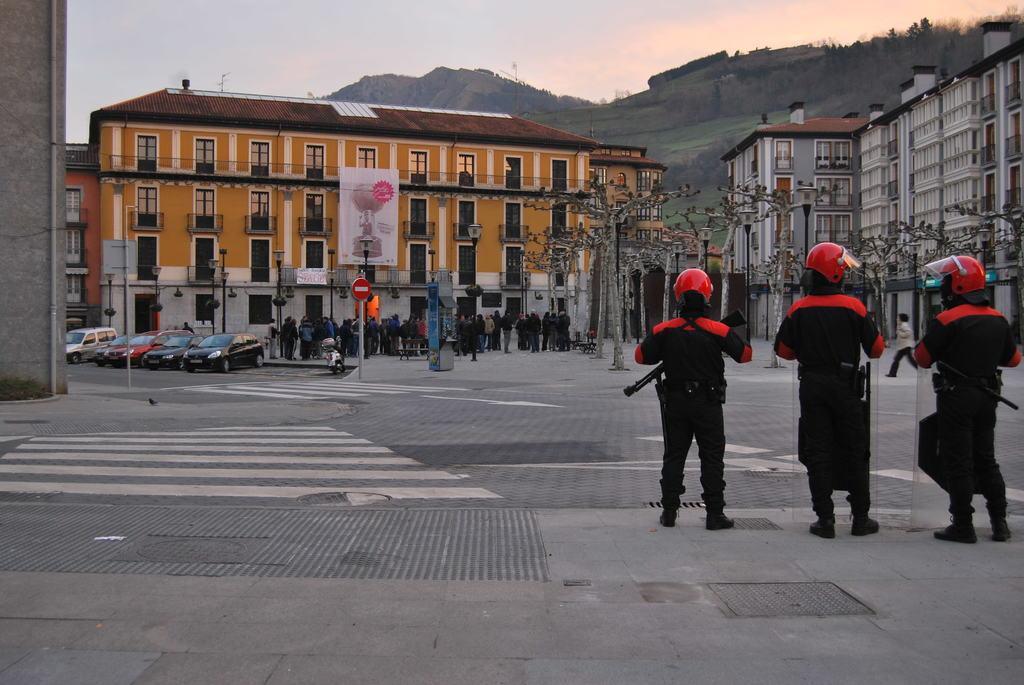How would you summarize this image in a sentence or two? In this image I can see three persons standing and wearing red and black color dress. Background I can see few vehicles on the road, few other persons standing, light poles. I can also see building in orange color and sky in white color. 